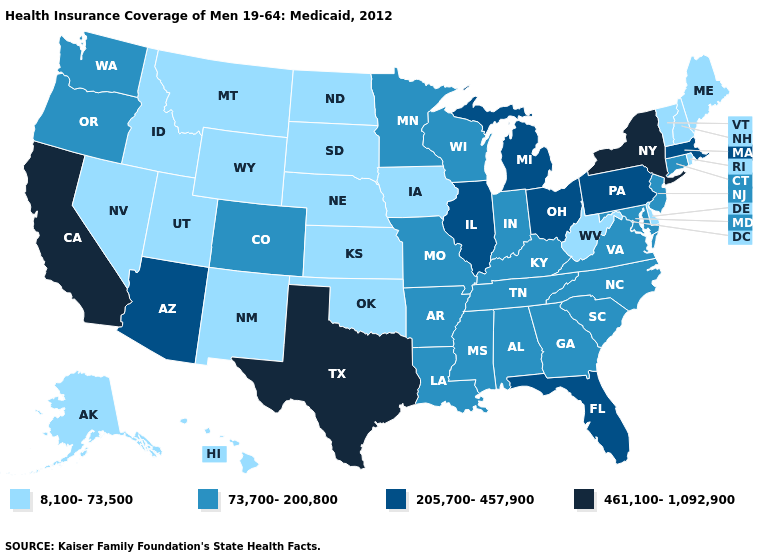Name the states that have a value in the range 73,700-200,800?
Be succinct. Alabama, Arkansas, Colorado, Connecticut, Georgia, Indiana, Kentucky, Louisiana, Maryland, Minnesota, Mississippi, Missouri, New Jersey, North Carolina, Oregon, South Carolina, Tennessee, Virginia, Washington, Wisconsin. Does Alabama have the highest value in the South?
Short answer required. No. What is the value of Alaska?
Short answer required. 8,100-73,500. Does Washington have a lower value than Idaho?
Be succinct. No. Among the states that border Oregon , does California have the highest value?
Answer briefly. Yes. What is the highest value in the USA?
Short answer required. 461,100-1,092,900. Name the states that have a value in the range 8,100-73,500?
Concise answer only. Alaska, Delaware, Hawaii, Idaho, Iowa, Kansas, Maine, Montana, Nebraska, Nevada, New Hampshire, New Mexico, North Dakota, Oklahoma, Rhode Island, South Dakota, Utah, Vermont, West Virginia, Wyoming. What is the highest value in the USA?
Quick response, please. 461,100-1,092,900. Does the first symbol in the legend represent the smallest category?
Write a very short answer. Yes. What is the lowest value in the MidWest?
Answer briefly. 8,100-73,500. What is the highest value in states that border Indiana?
Keep it brief. 205,700-457,900. What is the lowest value in states that border South Dakota?
Write a very short answer. 8,100-73,500. Among the states that border Wisconsin , which have the highest value?
Keep it brief. Illinois, Michigan. What is the value of Georgia?
Concise answer only. 73,700-200,800. What is the value of Minnesota?
Be succinct. 73,700-200,800. 